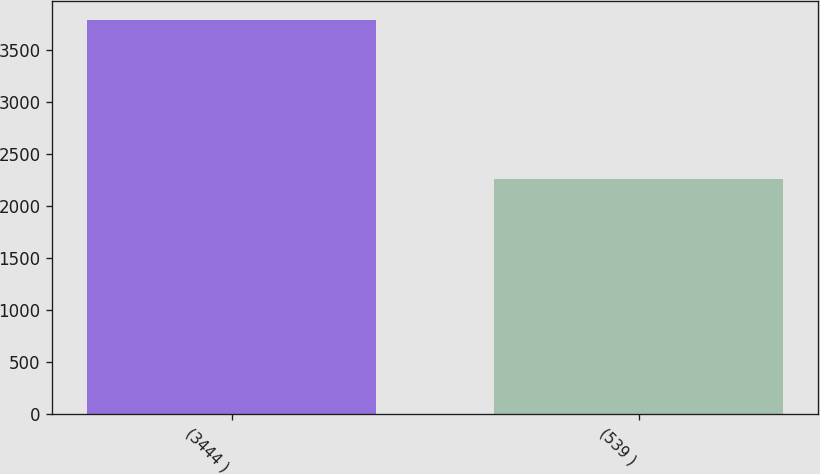Convert chart. <chart><loc_0><loc_0><loc_500><loc_500><bar_chart><fcel>(3444 )<fcel>(539 )<nl><fcel>3785<fcel>2259<nl></chart> 